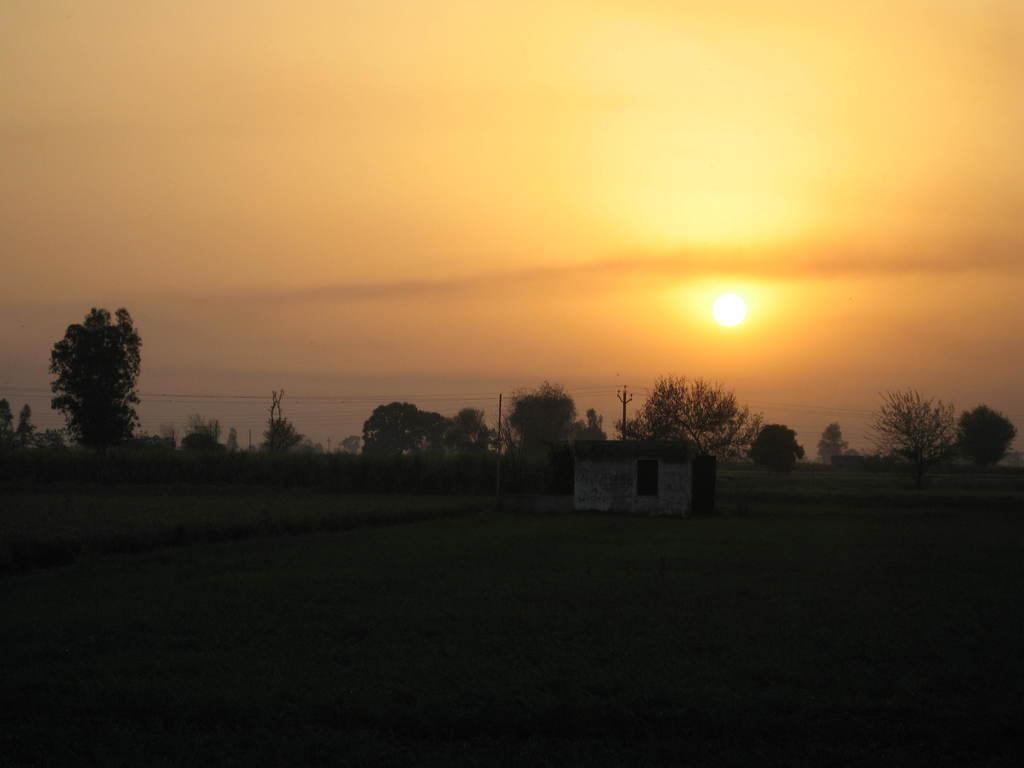In one or two sentences, can you explain what this image depicts? In the image we can see a house, grass, plant, trees, electric wires, electric pole, sky and the sun. 